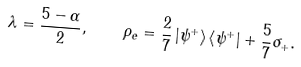<formula> <loc_0><loc_0><loc_500><loc_500>\lambda = \frac { 5 - \alpha } { 2 } , \quad \rho _ { e } = \frac { 2 } { 7 } \left | \psi ^ { + } \right > \left < \psi ^ { + } \right | + \frac { 5 } { 7 } \sigma _ { + } .</formula> 